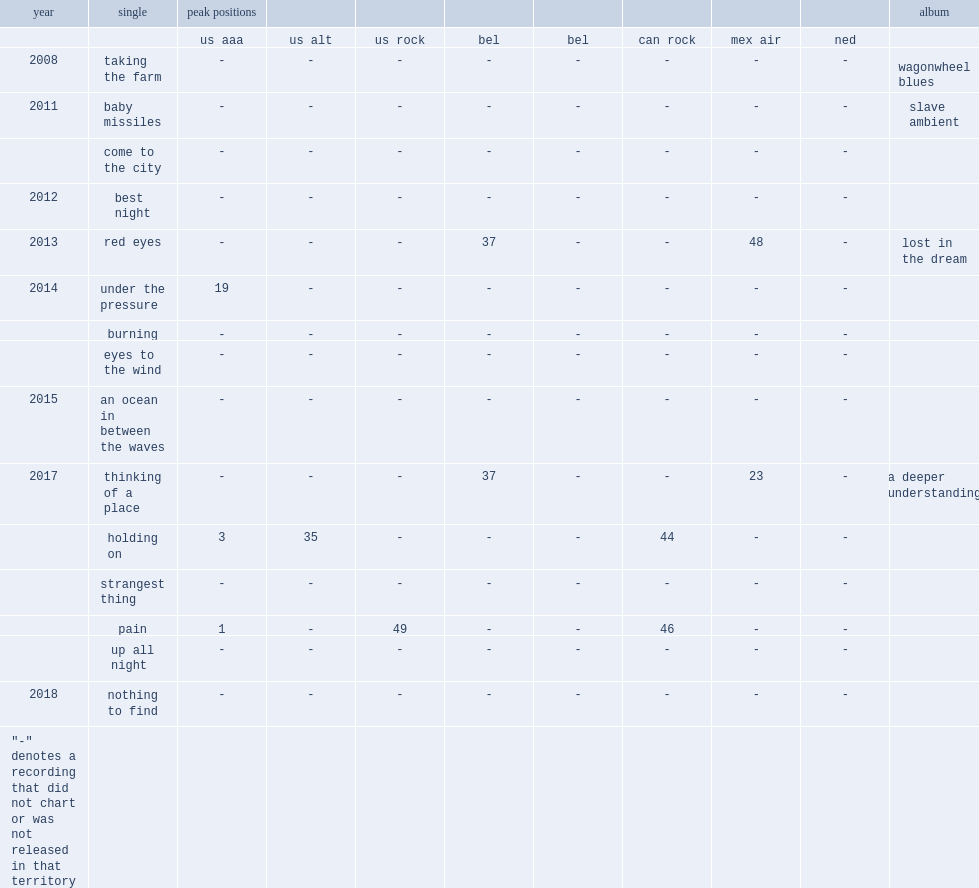In 2007, which album was relased by the war on drugs and had a song called "holding on"? A deeper understanding. 